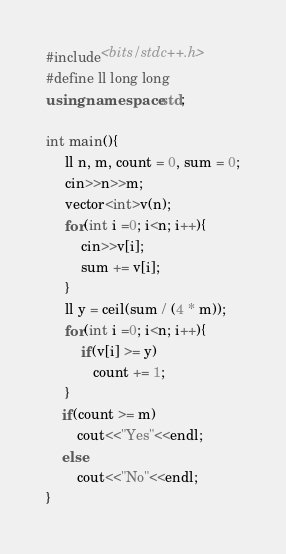<code> <loc_0><loc_0><loc_500><loc_500><_C++_>#include<bits/stdc++.h>
#define ll long long
using namespace std;

int main(){
	 ll n, m, count = 0, sum = 0;
     cin>>n>>m;
     vector<int>v(n);
     for(int i =0; i<n; i++){
         cin>>v[i];
         sum += v[i];
     }
     ll y = ceil(sum / (4 * m));
     for(int i =0; i<n; i++){
         if(v[i] >= y)
            count += 1;
     }
    if(count >= m)
        cout<<"Yes"<<endl;
    else
        cout<<"No"<<endl;
}</code> 